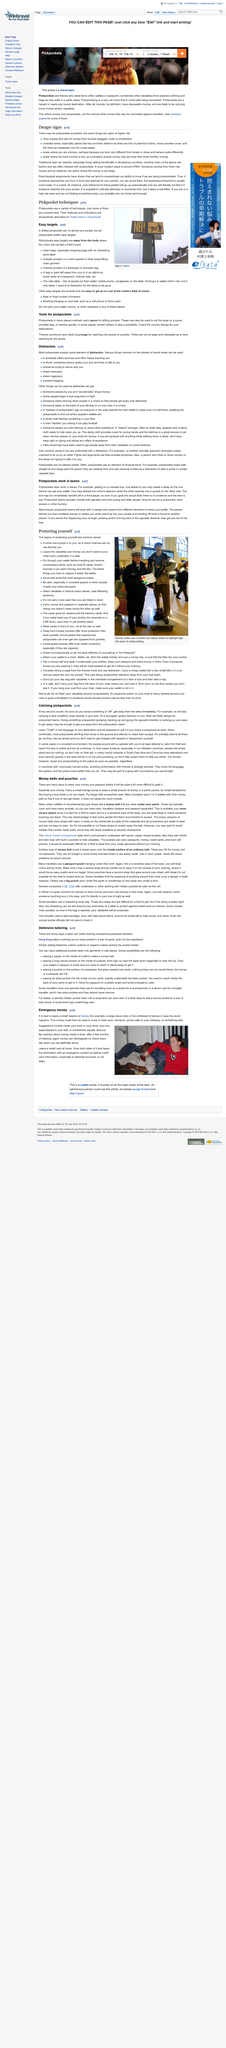Highlight a few significant elements in this photo. Pickpocketing, an age-old crime that has continually evolved, remains a prevalent criminal activity. In the event of emergency, the emergency fund can be used to cover hotel rooms, transportation, and calls to the embassy, to ensure the safety and well-being of the traveler. It is false that only young people are pickpockets. Pickpockets typically target easy targets. Pickpockets often target individuals who are distracted or away from their bodies, making them easy targets for theft. 